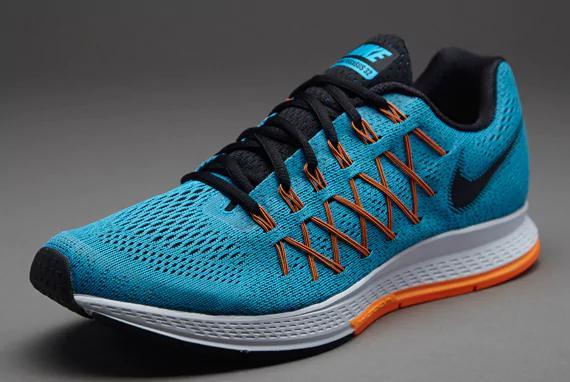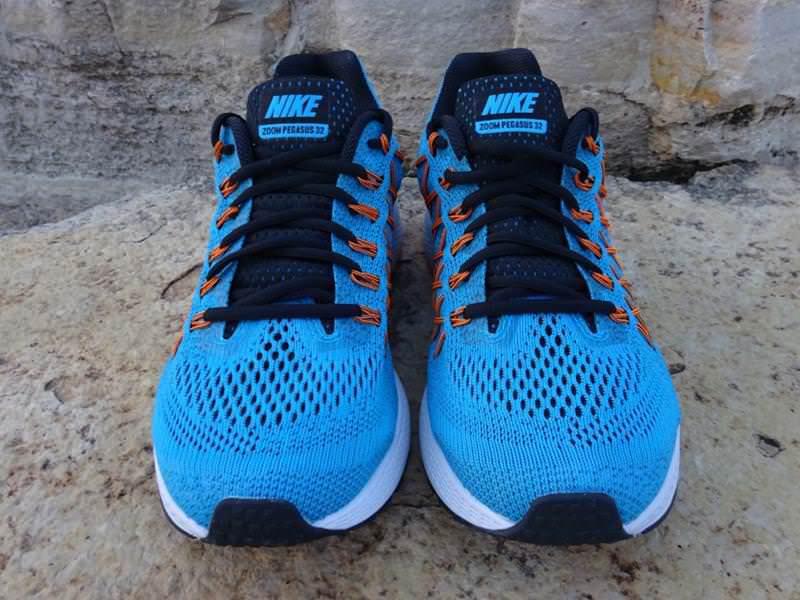The first image is the image on the left, the second image is the image on the right. Considering the images on both sides, is "A total of three shoes are shown." valid? Answer yes or no. Yes. 